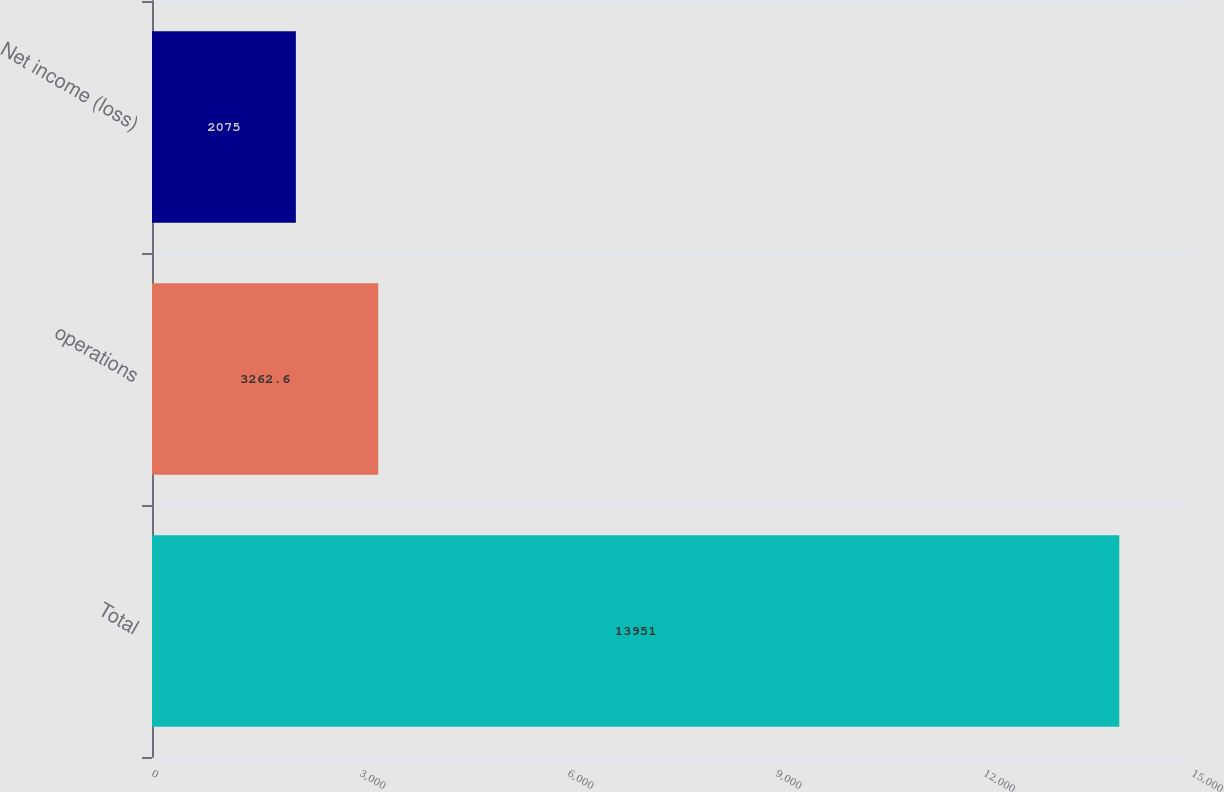<chart> <loc_0><loc_0><loc_500><loc_500><bar_chart><fcel>Total<fcel>operations<fcel>Net income (loss)<nl><fcel>13951<fcel>3262.6<fcel>2075<nl></chart> 